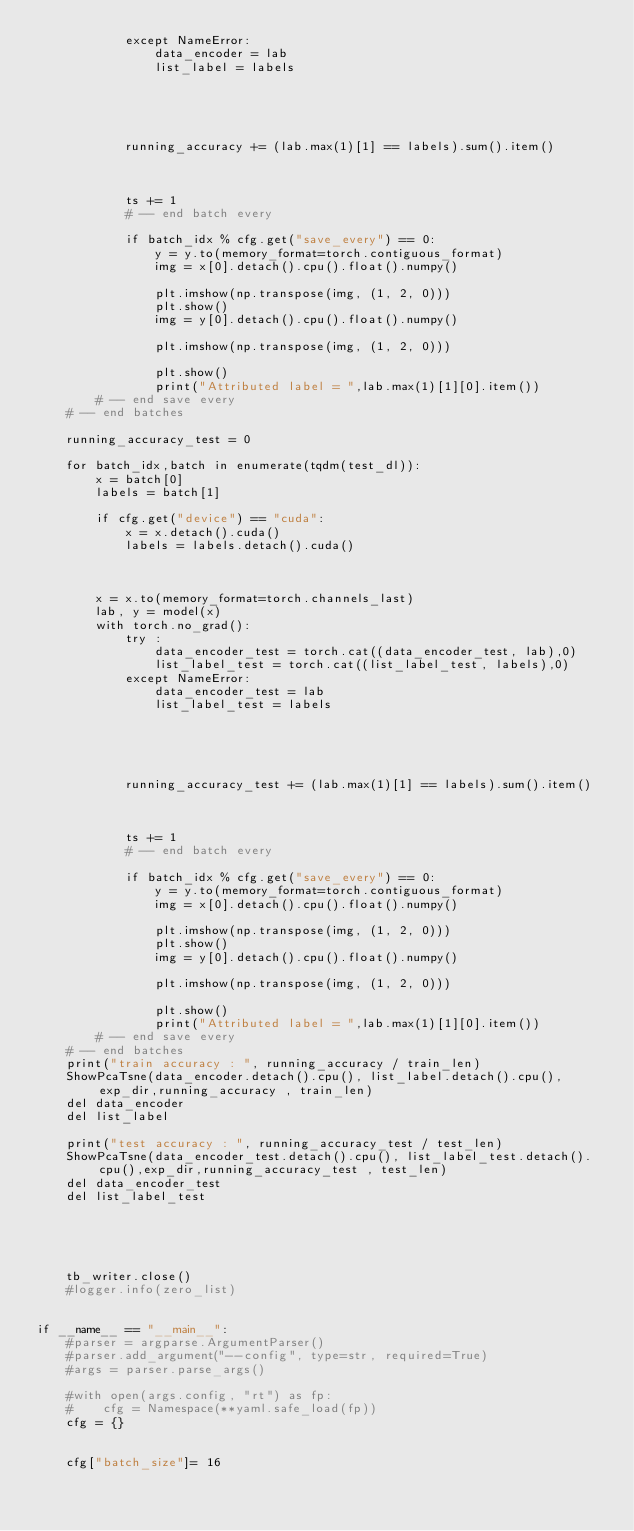Convert code to text. <code><loc_0><loc_0><loc_500><loc_500><_Python_>            except NameError:
                data_encoder = lab
                list_label = labels
    
            
    
            
    
            running_accuracy += (lab.max(1)[1] == labels).sum().item() 
    
    
    
            ts += 1
            # -- end batch every
    
            if batch_idx % cfg.get("save_every") == 0:
                y = y.to(memory_format=torch.contiguous_format)
                img = x[0].detach().cpu().float().numpy()
                
                plt.imshow(np.transpose(img, (1, 2, 0)))
                plt.show()
                img = y[0].detach().cpu().float().numpy()
                
                plt.imshow(np.transpose(img, (1, 2, 0)))
                
                plt.show()
                print("Attributed label = ",lab.max(1)[1][0].item())
        # -- end save every
    # -- end batches

    running_accuracy_test = 0
    
    for batch_idx,batch in enumerate(tqdm(test_dl)):
        x = batch[0]
        labels = batch[1]

        if cfg.get("device") == "cuda":
            x = x.detach().cuda()
            labels = labels.detach().cuda()



        x = x.to(memory_format=torch.channels_last)
        lab, y = model(x)
        with torch.no_grad():
            try : 
                data_encoder_test = torch.cat((data_encoder_test, lab),0)
                list_label_test = torch.cat((list_label_test, labels),0)
            except NameError:
                data_encoder_test = lab
                list_label_test = labels
    
            
    
            
    
            running_accuracy_test += (lab.max(1)[1] == labels).sum().item() 
    
    
    
            ts += 1
            # -- end batch every
    
            if batch_idx % cfg.get("save_every") == 0:
                y = y.to(memory_format=torch.contiguous_format)
                img = x[0].detach().cpu().float().numpy()
                
                plt.imshow(np.transpose(img, (1, 2, 0)))
                plt.show()
                img = y[0].detach().cpu().float().numpy()
                
                plt.imshow(np.transpose(img, (1, 2, 0)))
                
                plt.show()
                print("Attributed label = ",lab.max(1)[1][0].item())
        # -- end save every
    # -- end batches
    print("train accuracy : ", running_accuracy / train_len)
    ShowPcaTsne(data_encoder.detach().cpu(), list_label.detach().cpu(),exp_dir,running_accuracy , train_len)
    del data_encoder
    del list_label
    
    print("test accuracy : ", running_accuracy_test / test_len)
    ShowPcaTsne(data_encoder_test.detach().cpu(), list_label_test.detach().cpu(),exp_dir,running_accuracy_test , test_len)
    del data_encoder_test
    del list_label_test

    
        
       

    tb_writer.close()
    #logger.info(zero_list)
    

if __name__ == "__main__":
    #parser = argparse.ArgumentParser()
    #parser.add_argument("--config", type=str, required=True)
    #args = parser.parse_args()

    #with open(args.config, "rt") as fp:
    #    cfg = Namespace(**yaml.safe_load(fp))
    cfg = {}
    

    cfg["batch_size"]= 16</code> 